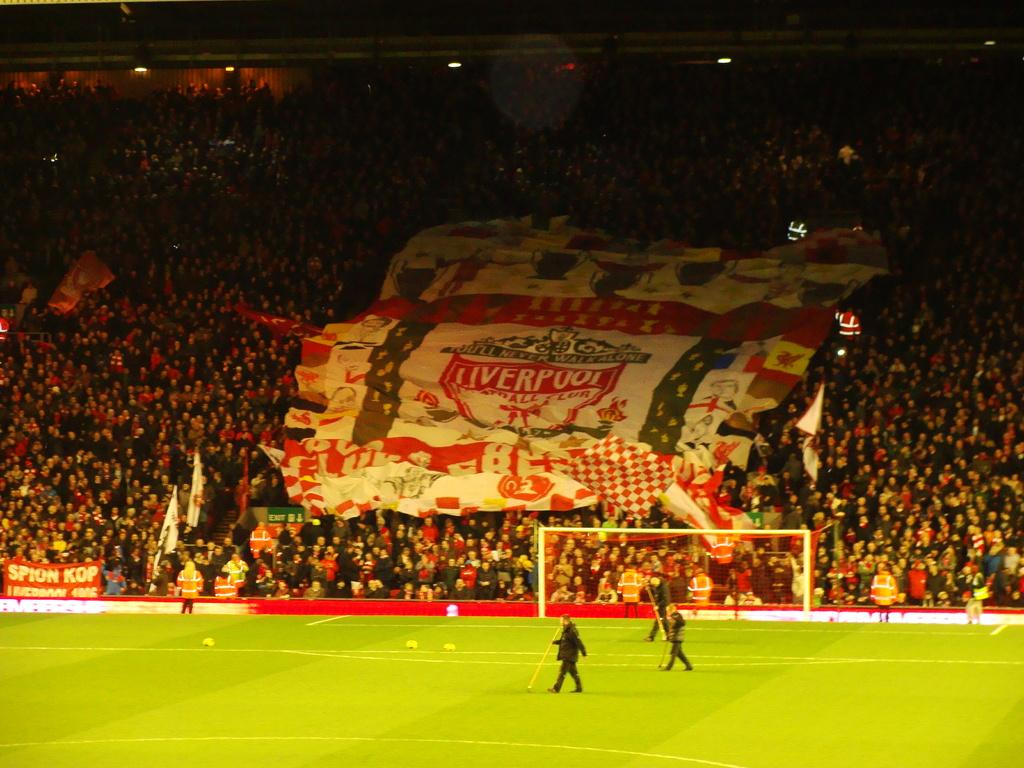<image>
Write a terse but informative summary of the picture. a soccer field and stadium covered in big blanket reading Liverpool in the stands 